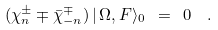<formula> <loc_0><loc_0><loc_500><loc_500>( \chi ^ { \pm } _ { n } \mp \bar { \chi } ^ { \mp } _ { - n } ) \, | \, \Omega , F \rangle _ { 0 } \ = \ 0 \ \ .</formula> 